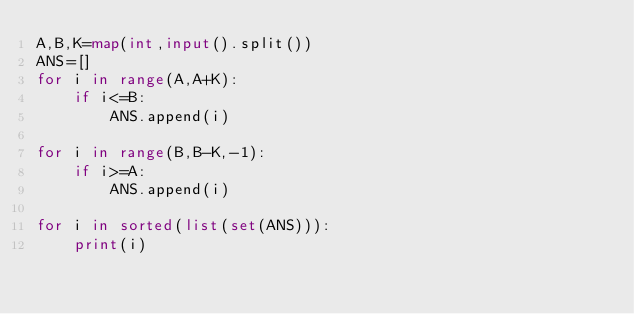Convert code to text. <code><loc_0><loc_0><loc_500><loc_500><_Python_>A,B,K=map(int,input().split())
ANS=[]
for i in range(A,A+K):
    if i<=B:
        ANS.append(i)

for i in range(B,B-K,-1):
    if i>=A:
        ANS.append(i)

for i in sorted(list(set(ANS))):
    print(i)</code> 